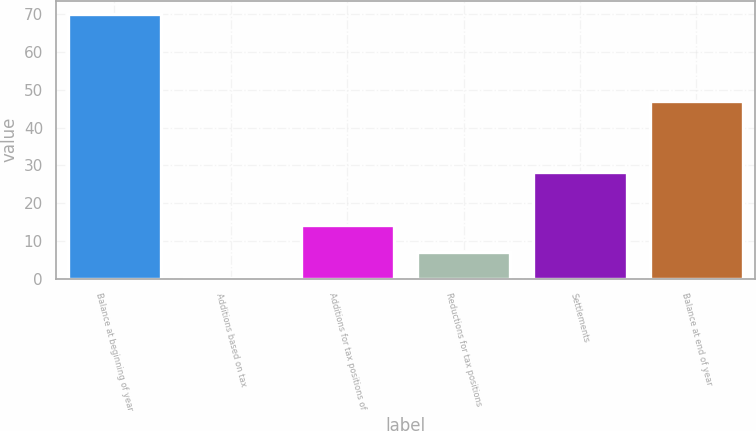Convert chart. <chart><loc_0><loc_0><loc_500><loc_500><bar_chart><fcel>Balance at beginning of year<fcel>Additions based on tax<fcel>Additions for tax positions of<fcel>Reductions for tax positions<fcel>Settlements<fcel>Balance at end of year<nl><fcel>70.1<fcel>0.2<fcel>14.18<fcel>7.19<fcel>28.16<fcel>47<nl></chart> 